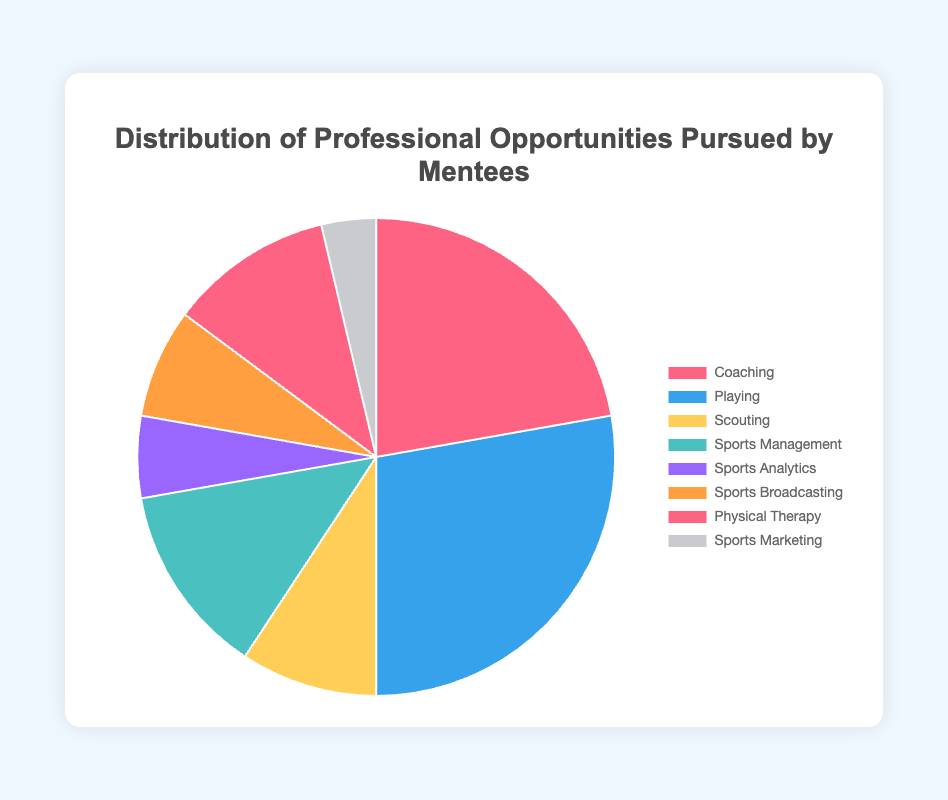Which career pursuit is the most popular among mentees? The slice representing "Playing" is the largest, indicating it has the greatest count of 15.
Answer: Playing Which two career pursuits have the smallest counts in the distribution? The slices representing "Sports Analytics" and "Sports Marketing" are the smallest with counts of 3 and 2 respectively.
Answer: Sports Analytics and Sports Marketing How many mentees pursued either Coaching or Physical Therapy careers? The counts for Coaching and Physical Therapy are 12 and 6 respectively. Adding them together gives 12 + 6 = 18.
Answer: 18 What is the difference in count between Playing and Scouting? Playing has a count of 15, while Scouting has a count of 5. The difference is 15 - 5 = 10.
Answer: 10 Which career pursuit is represented by a blue slice? Referencing the typical color scheme, the blue slice is associated with "Playing," which also corresponds to the highest count of 15.
Answer: Playing How many more people pursued Coaching than Sports Management? Coaching has a count of 12 while Sports Management has a count of 7. The difference is 12 - 7 = 5.
Answer: 5 Which career opportunities have exactly half the count of Coaching? Coaching has a count of 12, so half of that is 12 / 2 = 6. Physical Therapy has exactly 6 mentees.
Answer: Physical Therapy What is the total number of mentees represented in the chart? Adding up all the counts: 12 (Coaching) + 15 (Playing) + 5 (Scouting) + 7 (Sports Management) + 3 (Sports Analytics) + 4 (Sports Broadcasting) + 6 (Physical Therapy) + 2 (Sports Marketing) = 54.
Answer: 54 Which career has a yellow slice? Referencing typical color schemes, the yellow slice corresponds to "Scouting" with a count of 5.
Answer: Scouting 